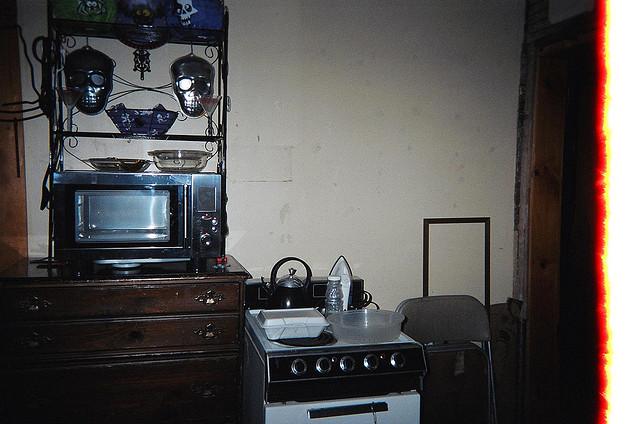Is this a Wall Street banker's kitchen?
Be succinct. No. What color is the tea kettle?
Short answer required. Black. What is on the stove?
Concise answer only. Container. 